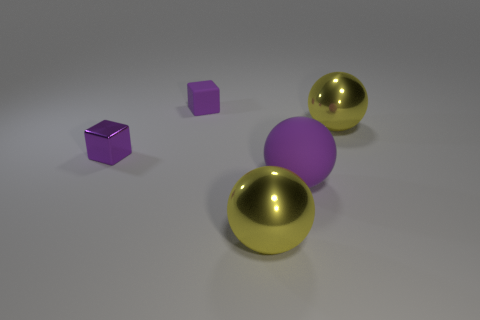There is a small purple metal cube to the left of the big purple matte ball; is there a shiny sphere that is behind it? yes 